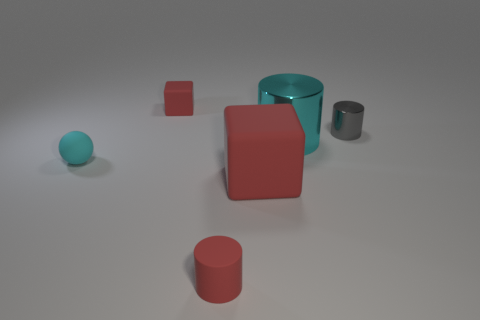Subtract all gray metallic cylinders. How many cylinders are left? 2 Add 2 large red matte spheres. How many objects exist? 8 Subtract all cyan cylinders. How many cylinders are left? 2 Add 1 large cylinders. How many large cylinders are left? 2 Add 3 shiny things. How many shiny things exist? 5 Subtract 0 gray cubes. How many objects are left? 6 Subtract all blocks. How many objects are left? 4 Subtract 1 cylinders. How many cylinders are left? 2 Subtract all red spheres. Subtract all brown cubes. How many spheres are left? 1 Subtract all big green rubber objects. Subtract all small rubber spheres. How many objects are left? 5 